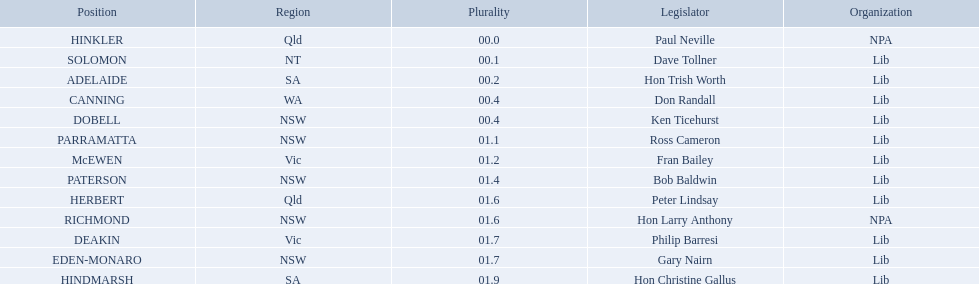What state does hinkler belong too? Qld. What is the majority of difference between sa and qld? 01.9. 